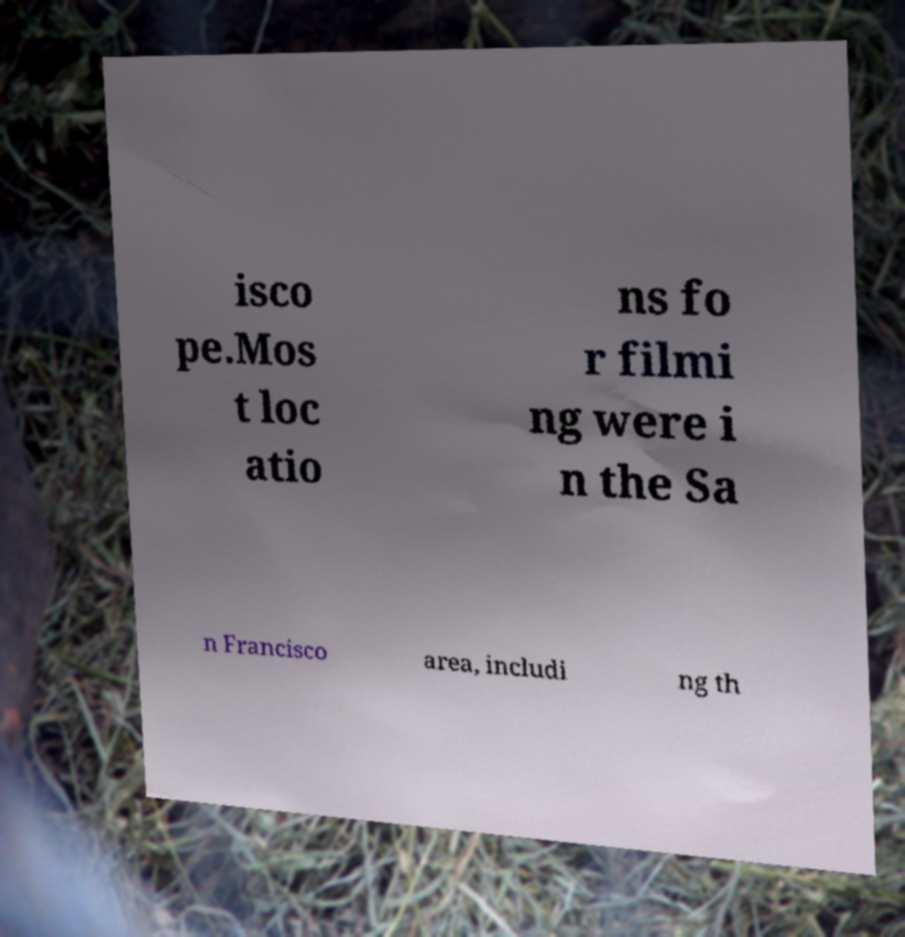Can you read and provide the text displayed in the image?This photo seems to have some interesting text. Can you extract and type it out for me? isco pe.Mos t loc atio ns fo r filmi ng were i n the Sa n Francisco area, includi ng th 